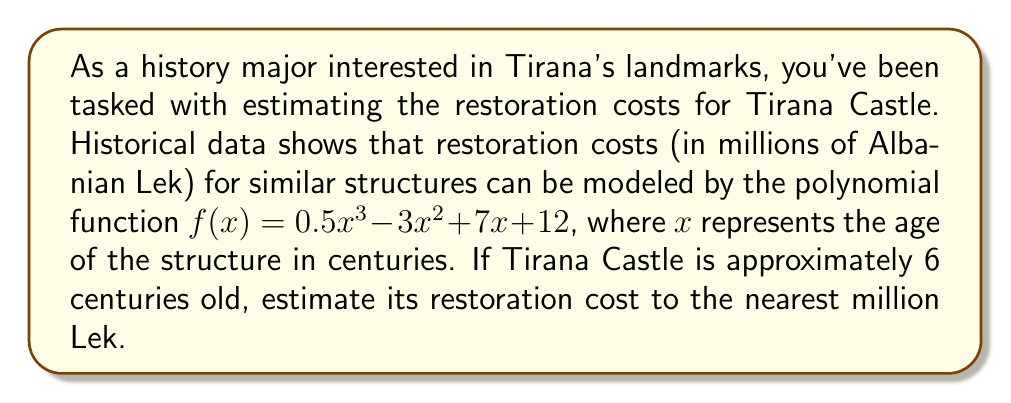Solve this math problem. To solve this problem, we need to follow these steps:

1) We are given the polynomial function:
   $f(x) = 0.5x^3 - 3x^2 + 7x + 12$

2) We need to evaluate this function at $x = 6$ (since the castle is 6 centuries old):
   $f(6) = 0.5(6^3) - 3(6^2) + 7(6) + 12$

3) Let's calculate each term:
   - $0.5(6^3) = 0.5(216) = 108$
   - $3(6^2) = 3(36) = 108$
   - $7(6) = 42$
   - $12$ remains as is

4) Now, let's sum these terms:
   $f(6) = 108 - 108 + 42 + 12 = 54$

5) The result, 54, represents 54 million Albanian Lek.

6) The question asks to round to the nearest million, but 54 million is already a whole number, so no further rounding is necessary.
Answer: The estimated restoration cost for Tirana Castle is 54 million Albanian Lek. 